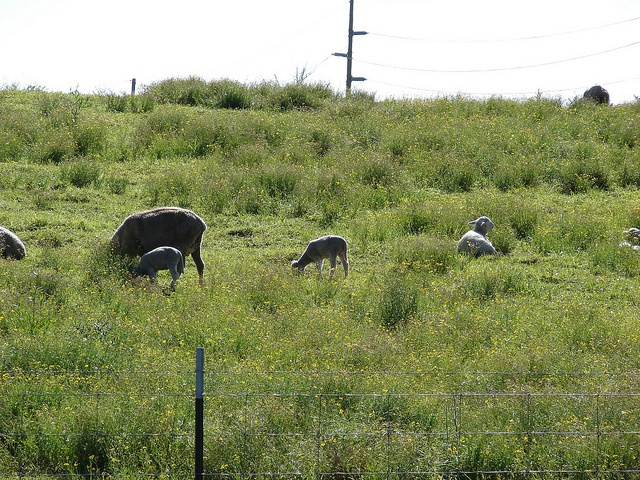Describe the objects in this image and their specific colors. I can see sheep in white, black, gray, darkgreen, and darkgray tones, sheep in white, black, gray, darkgreen, and darkgray tones, sheep in white, black, gray, and darkgreen tones, sheep in white, gray, black, lightgray, and darkgray tones, and sheep in white, black, gray, lightgray, and darkgreen tones in this image. 